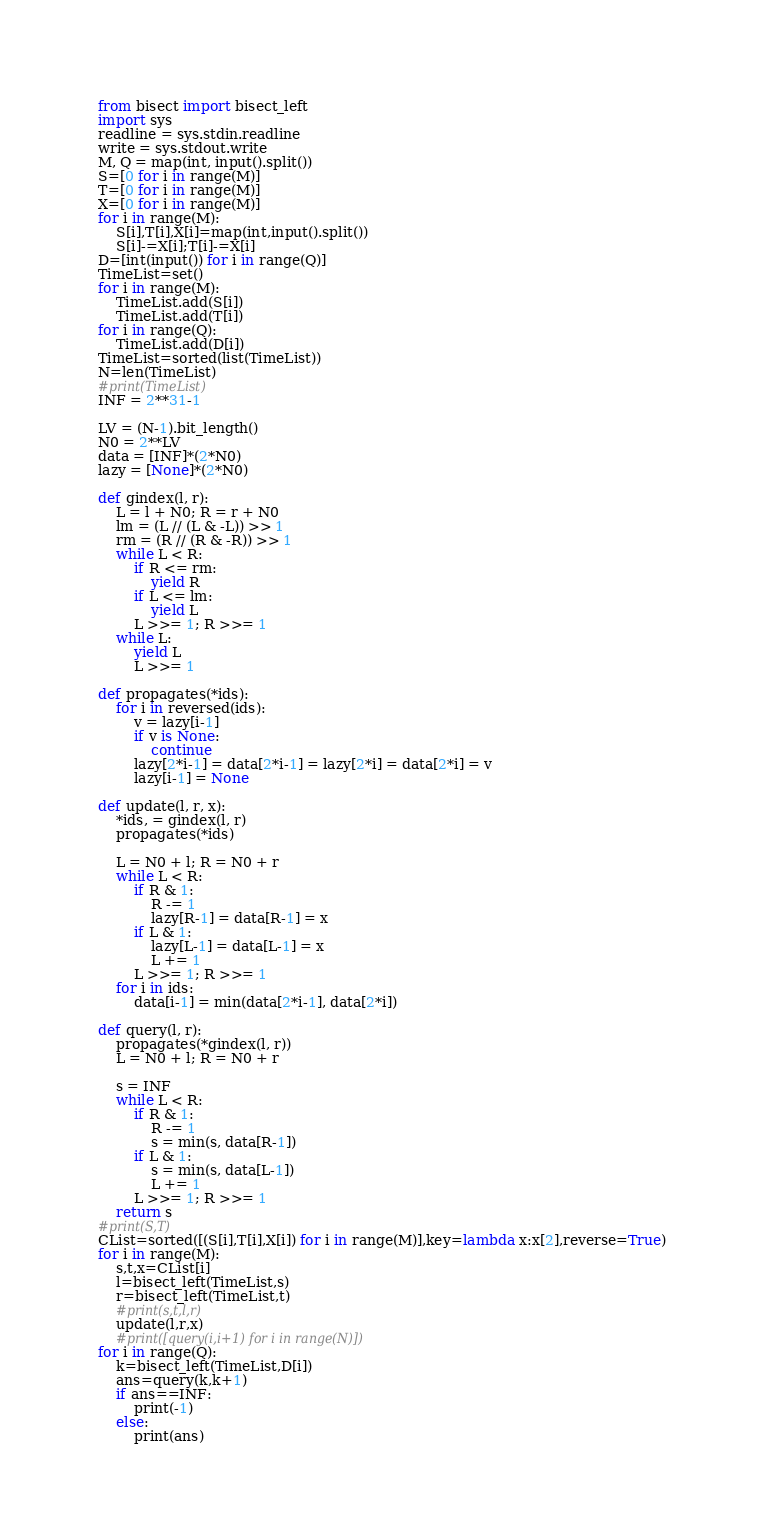<code> <loc_0><loc_0><loc_500><loc_500><_Python_>from bisect import bisect_left
import sys
readline = sys.stdin.readline
write = sys.stdout.write
M, Q = map(int, input().split())
S=[0 for i in range(M)]
T=[0 for i in range(M)]
X=[0 for i in range(M)]
for i in range(M):
    S[i],T[i],X[i]=map(int,input().split())
    S[i]-=X[i];T[i]-=X[i]
D=[int(input()) for i in range(Q)]
TimeList=set()
for i in range(M):
    TimeList.add(S[i])
    TimeList.add(T[i])
for i in range(Q):
    TimeList.add(D[i])
TimeList=sorted(list(TimeList))
N=len(TimeList)
#print(TimeList)
INF = 2**31-1
 
LV = (N-1).bit_length()
N0 = 2**LV
data = [INF]*(2*N0)
lazy = [None]*(2*N0)
 
def gindex(l, r):
    L = l + N0; R = r + N0
    lm = (L // (L & -L)) >> 1
    rm = (R // (R & -R)) >> 1
    while L < R:
        if R <= rm:
            yield R
        if L <= lm:
            yield L
        L >>= 1; R >>= 1
    while L:
        yield L
        L >>= 1
 
def propagates(*ids):
    for i in reversed(ids):
        v = lazy[i-1]
        if v is None:
            continue
        lazy[2*i-1] = data[2*i-1] = lazy[2*i] = data[2*i] = v
        lazy[i-1] = None
 
def update(l, r, x):
    *ids, = gindex(l, r)
    propagates(*ids)
 
    L = N0 + l; R = N0 + r
    while L < R:
        if R & 1:
            R -= 1
            lazy[R-1] = data[R-1] = x
        if L & 1:
            lazy[L-1] = data[L-1] = x
            L += 1
        L >>= 1; R >>= 1
    for i in ids:
        data[i-1] = min(data[2*i-1], data[2*i])
 
def query(l, r):
    propagates(*gindex(l, r))
    L = N0 + l; R = N0 + r
 
    s = INF
    while L < R:
        if R & 1:
            R -= 1
            s = min(s, data[R-1])
        if L & 1:
            s = min(s, data[L-1])
            L += 1
        L >>= 1; R >>= 1
    return s
#print(S,T)
CList=sorted([(S[i],T[i],X[i]) for i in range(M)],key=lambda x:x[2],reverse=True)
for i in range(M):
    s,t,x=CList[i]
    l=bisect_left(TimeList,s)
    r=bisect_left(TimeList,t)
    #print(s,t,l,r)
    update(l,r,x)
    #print([query(i,i+1) for i in range(N)])
for i in range(Q):
    k=bisect_left(TimeList,D[i])
    ans=query(k,k+1)
    if ans==INF:
        print(-1)
    else:
        print(ans)</code> 